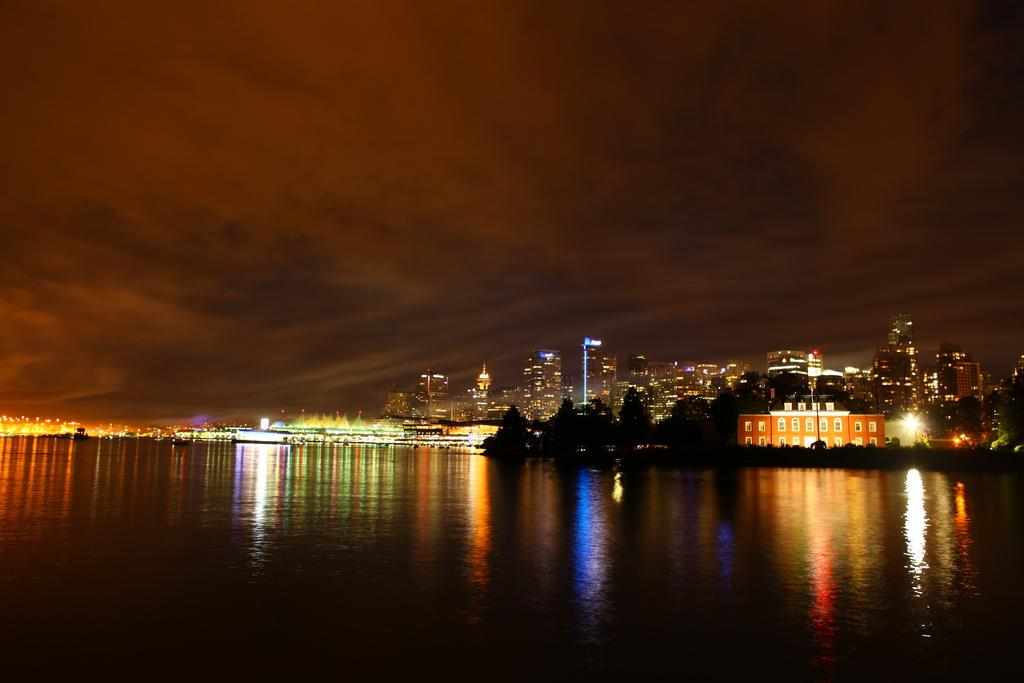What is visible in the image that is not a solid structure? Water is visible in the image. What type of structures can be seen in the image? Buildings and ships are visible in the image. What type of vegetation is present in the image? Trees are present in the image. What is visible in the sky in the image? The sky is visible in the image, and clouds are present. Can you see any patches of iron on the ships in the image? There is no mention of iron or patches in the image, and the image does not show any details of the ships' materials. 